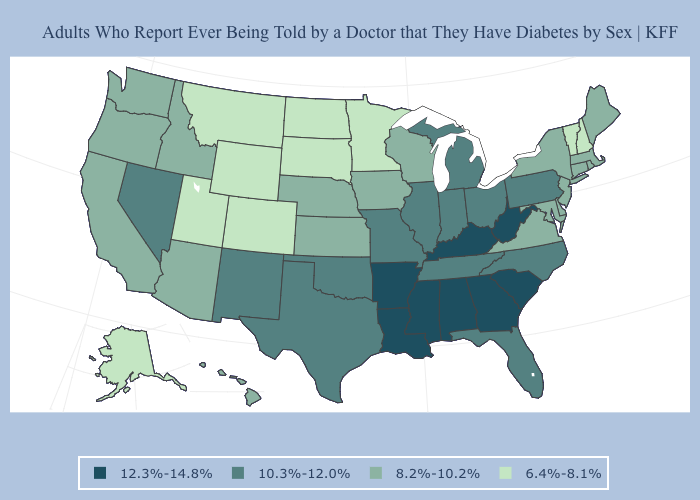What is the value of Oklahoma?
Keep it brief. 10.3%-12.0%. What is the value of Tennessee?
Write a very short answer. 10.3%-12.0%. Does Illinois have a lower value than Arkansas?
Write a very short answer. Yes. Among the states that border Louisiana , which have the lowest value?
Answer briefly. Texas. Does North Dakota have the lowest value in the USA?
Short answer required. Yes. What is the lowest value in the West?
Concise answer only. 6.4%-8.1%. What is the value of Oklahoma?
Be succinct. 10.3%-12.0%. Name the states that have a value in the range 8.2%-10.2%?
Concise answer only. Arizona, California, Connecticut, Delaware, Hawaii, Idaho, Iowa, Kansas, Maine, Maryland, Massachusetts, Nebraska, New Jersey, New York, Oregon, Rhode Island, Virginia, Washington, Wisconsin. Among the states that border New Hampshire , which have the highest value?
Concise answer only. Maine, Massachusetts. What is the value of Ohio?
Quick response, please. 10.3%-12.0%. What is the lowest value in the USA?
Answer briefly. 6.4%-8.1%. What is the value of Wisconsin?
Quick response, please. 8.2%-10.2%. What is the value of Indiana?
Give a very brief answer. 10.3%-12.0%. Name the states that have a value in the range 8.2%-10.2%?
Concise answer only. Arizona, California, Connecticut, Delaware, Hawaii, Idaho, Iowa, Kansas, Maine, Maryland, Massachusetts, Nebraska, New Jersey, New York, Oregon, Rhode Island, Virginia, Washington, Wisconsin. What is the value of Virginia?
Short answer required. 8.2%-10.2%. 